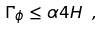<formula> <loc_0><loc_0><loc_500><loc_500>\Gamma _ { \phi } \leq \alpha 4 H \ ,</formula> 